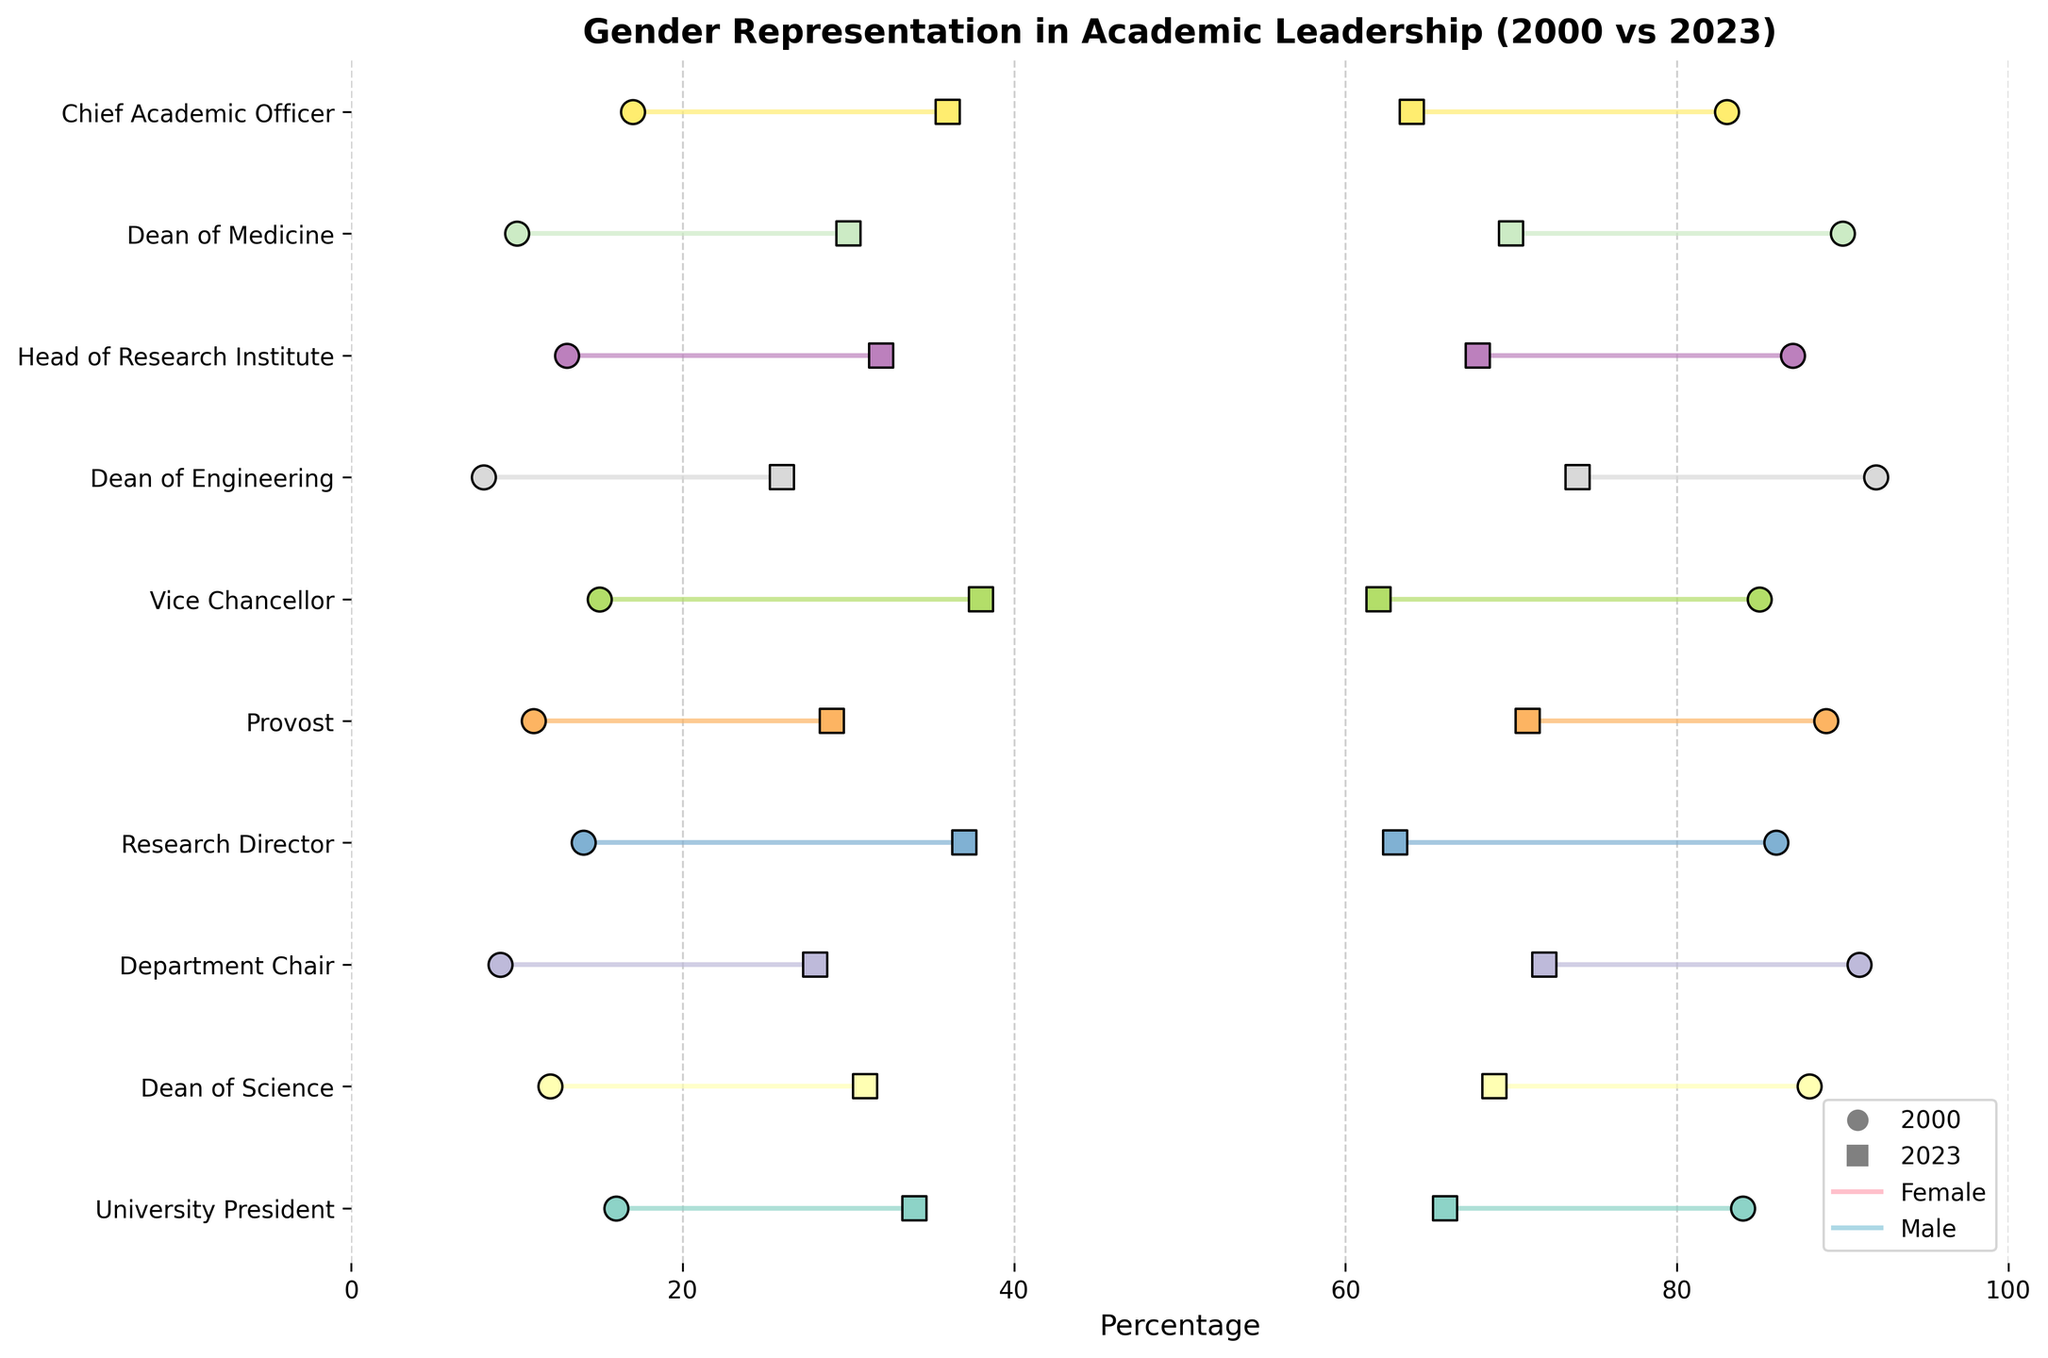What is the title of the plot? The title of the plot is given at the top and summarizes the data being visualized.
Answer: Gender Representation in Academic Leadership (2000 vs 2023) What do the circles and squares represent in the plot? Circles represent data points from the year 2000, and squares represent data points from the year 2023, as indicated by the legend at the bottom.
Answer: Circles for 2000, squares for 2023 Which position showed the largest increase in female representation from 2000 to 2023? Compare the difference in female percentages between 2000 and 2023 for all positions. The largest increase is observed in the position of 'Vice Chancellor' in Oceania, where female representation increased by 23% (from 15% to 38%).
Answer: Vice Chancellor, Oceania Which continent has the highest percentage of female University Presidents in 2023? Look for the 'University President' position and check the female percentage for each continent in 2023. North America has the highest percentage at 34%.
Answer: North America In which continent did male representation decrease the most for the 'Research Director' position from 2000 to 2023? For the 'Research Director' position, calculate the decrease in male percentage (2000 - 2023) for each continent. The largest decrease for this position is in Africa, where male representation decreased by 23% (from 86% to 63%).
Answer: Africa What is the average percentage of female leaders across all positions globally in 2023? Sum up the female percentages for all positions in 2023 and divide by the number of positions. The sum is 285, and there are 10 positions, so the average is 285/10 = 28.5%.
Answer: 28.5% Did any positions have an increase in both female and male representation from 2000 to 2023? Examine each position to see if both female and male percentages increased from 2000 to 2023. None of the positions show an increase in both female and male representation simultaneously.
Answer: No What trend can be observed in the gender representation difference between 2000 and 2023 for the position of 'Dean of Medicine' in Asia? Calculate the difference in representation between male and female for both years and compare them. In 2000, the difference was 80% (90% male - 10% female), and in 2023, it decreased to 40% (70% male - 30% female). The trend shows that the gender gap is decreasing.
Answer: Decreasing gender gap Which position had the smallest decrease in male representation from 2000 to 2023? Compare the decrease in male percentages for all positions. The smallest decrease is for 'Chief Academic Officer' in Africa, where male representation only decreased by 19% (from 83% to 64%).
Answer: Chief Academic Officer, Africa 